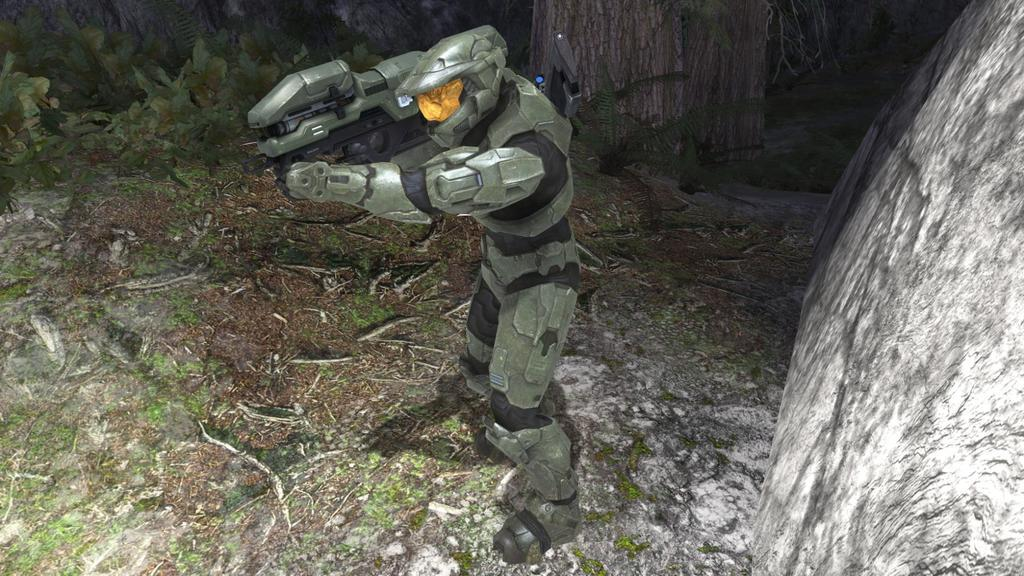What type of image is being described? The image appears to be animated. What is the main subject in the center of the image? There is a machine holding an object in the center of the image. How is the machine positioned in the image? The machine is standing. What type of vegetation can be seen in the image? There are green leaves and plants in the image. What type of natural elements are present in the image? There are rocks in the image. Can you describe any other items in the image? There are other unspecified items in the image. What type of coat is the machine wearing in the image? There is no coat present in the image, as the main subject is a machine. 